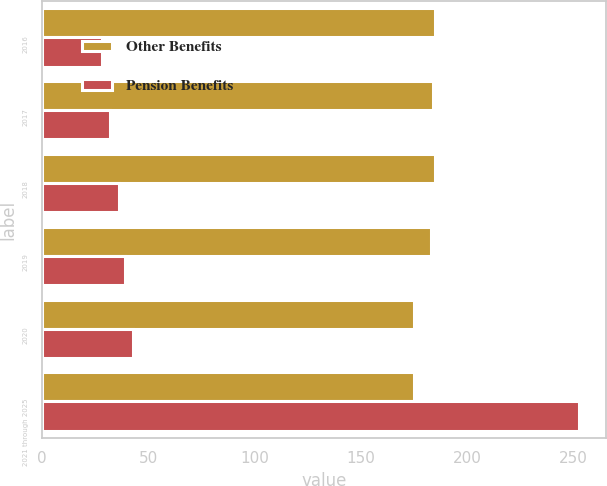<chart> <loc_0><loc_0><loc_500><loc_500><stacked_bar_chart><ecel><fcel>2016<fcel>2017<fcel>2018<fcel>2019<fcel>2020<fcel>2021 through 2025<nl><fcel>Other Benefits<fcel>185<fcel>184<fcel>185<fcel>183<fcel>175<fcel>175<nl><fcel>Pension Benefits<fcel>28<fcel>32<fcel>36<fcel>39<fcel>43<fcel>253<nl></chart> 